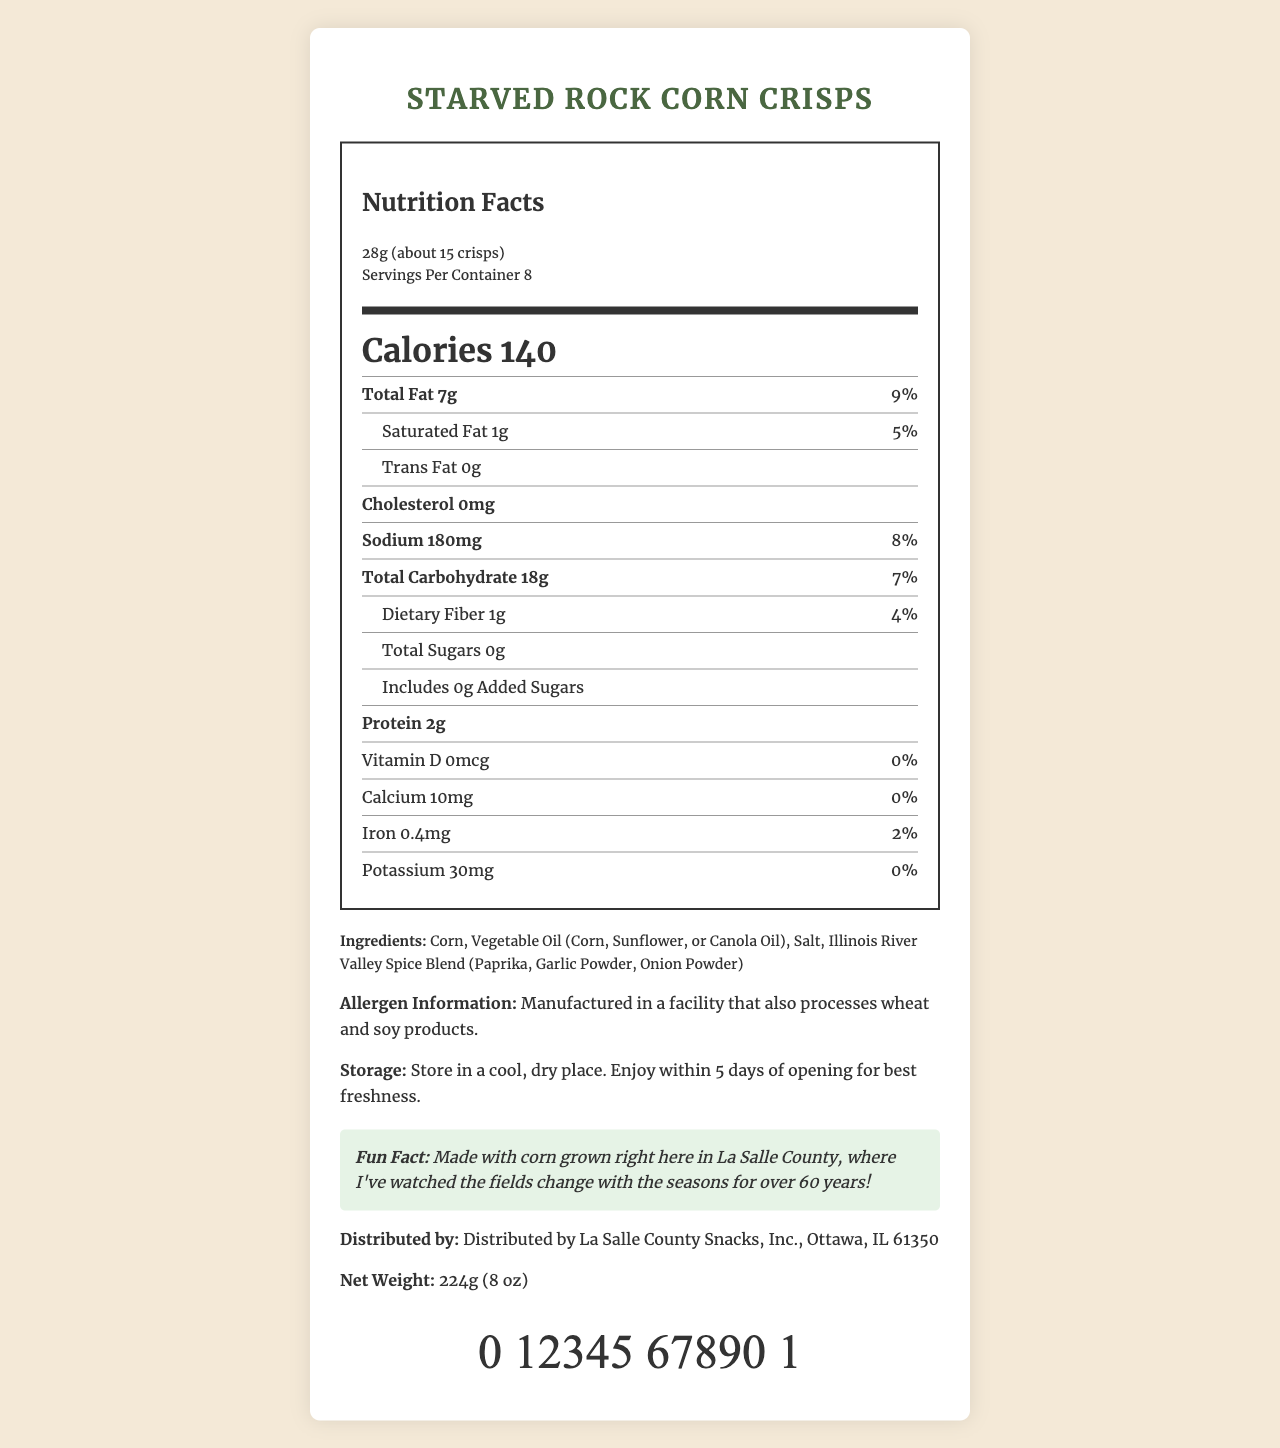what is the serving size of the Starved Rock Corn Crisps? The serving size is listed under the nutrition header in the document as "28g (about 15 crisps)".
Answer: 28g (about 15 crisps) how many calories are in one serving of the Starved Rock Corn Crisps? The document clearly states "Calories 140" in the section describing the nutritional content.
Answer: 140 how much total fat is in a serving? The total fat content per serving is listed as "Total Fat 7g" in the nutritional information section.
Answer: 7g what percentage of the daily value of sodium does one serving provide? The document shows that one serving contains 180mg of sodium, which is 8% of the daily value.
Answer: 8% does this product contain any trans fat? The document states "Trans Fat 0g", indicating there is no trans fat in the product.
Answer: No how much protein is there in a serving? The nutritional facts state that there are 2g of protein per serving.
Answer: 2g which of the following is NOT an ingredient in Starved Rock Corn Crisps? A. Corn B. Wheat C. Salt D. Vegetable Oil Corn, Salt, and Vegetable Oil are listed as ingredients, while Wheat is mentioned as an allergen information related to the manufacturing facility.
Answer: B how many servings are there per container? A. 6 B. 7 C. 8 D. 9 The document specifies that there are "Servings Per Container 8".
Answer: C true or false: This snack contains added sugars. The document states "Includes 0g Added Sugars", indicating that there are no added sugars.
Answer: False describe the fun fact about the Starved Rock Corn Crisps. The fun fact section mentions that the corn is grown in La Salle County and ties it to the personal experience.
Answer: Made with corn grown right here in La Salle County, where I've watched the fields change with the seasons for over 60 years! what is the net weight of the Starved Rock Corn Crisps container? The net weight is listed directly in the document as "224g (8 oz)".
Answer: 224g (8 oz) can we determine the price of the Starved Rock Corn Crisps from this document? The document provides detailed nutritional information and other details, but does not mention the price of the product.
Answer: Cannot be determined what are the storage instructions for this product? The storage instructions are stated clearly in the document.
Answer: Store in a cool, dry place. Enjoy within 5 days of opening for best freshness. what is the allergen information provided? The allergen information indicates potential cross-contamination with wheat and soy products processed in the same facility.
Answer: Manufactured in a facility that also processes wheat and soy products. who is the manufacturer of Starved Rock Corn Crisps? The document states that the manufacturer is "La Salle County Snacks, Inc." located in Ottawa, IL 61350.
Answer: La Salle County Snacks, Inc. summarize the document. This is a detailed description of the entire document, summarizing the nutrition facts, ingredients, and other relevant details for the Starved Rock Corn Crisps.
Answer: The document provides the nutrition facts for Starved Rock Corn Crisps, a locally produced snack in La Salle County. It includes serving size, calories, fat, cholesterol, sodium, carbohydrates, dietary fibers, sugars, protein, and other micro-nutrients, along with a list of ingredients. Allergy and storage information are also included. The document further provides a fun fact about the product being made from locally grown corn, distribution details, net weight, and a barcode. 